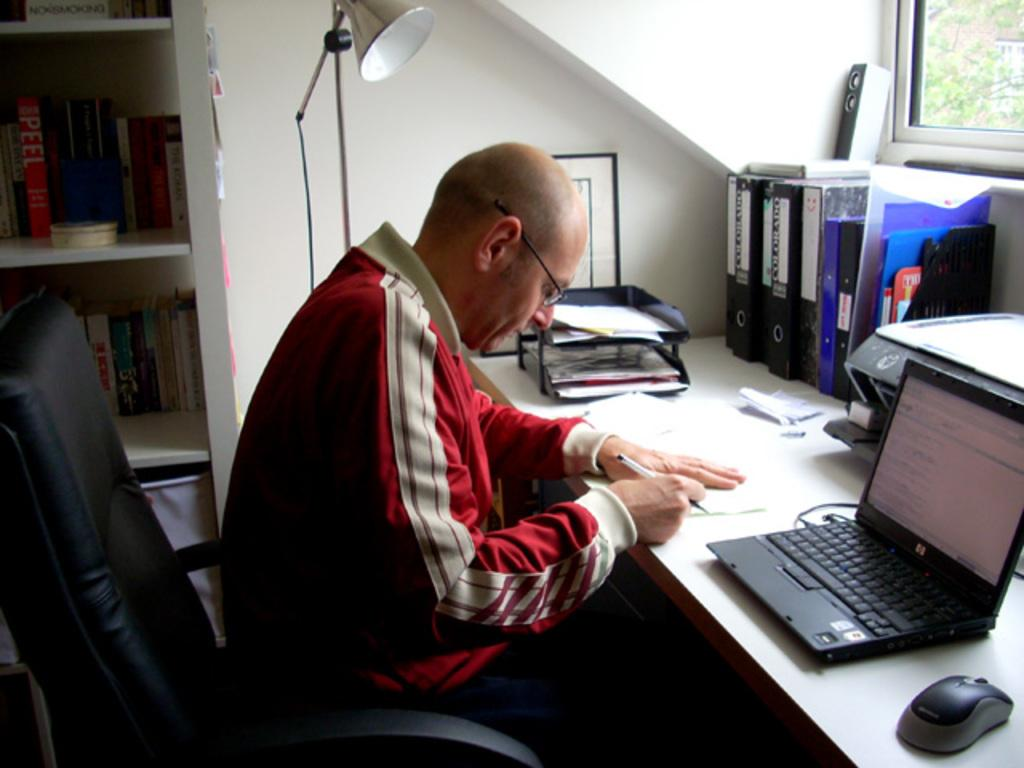What is the man in the image doing? The man is sitting at a table in the image. What object is on the table that the man might be using? There is a laptop on the table that the man might be using. What other items are on the table besides the laptop? There is a mouse, pieces of paper, file records, and other items on the table. What is the source of light for the man in the image? There is a lamp beside the man, which provides light. What is the lamp's structure like? The lamp has a stand. How does the man twist the icicle in the image? There is no icicle present in the image, so the man cannot twist one. 